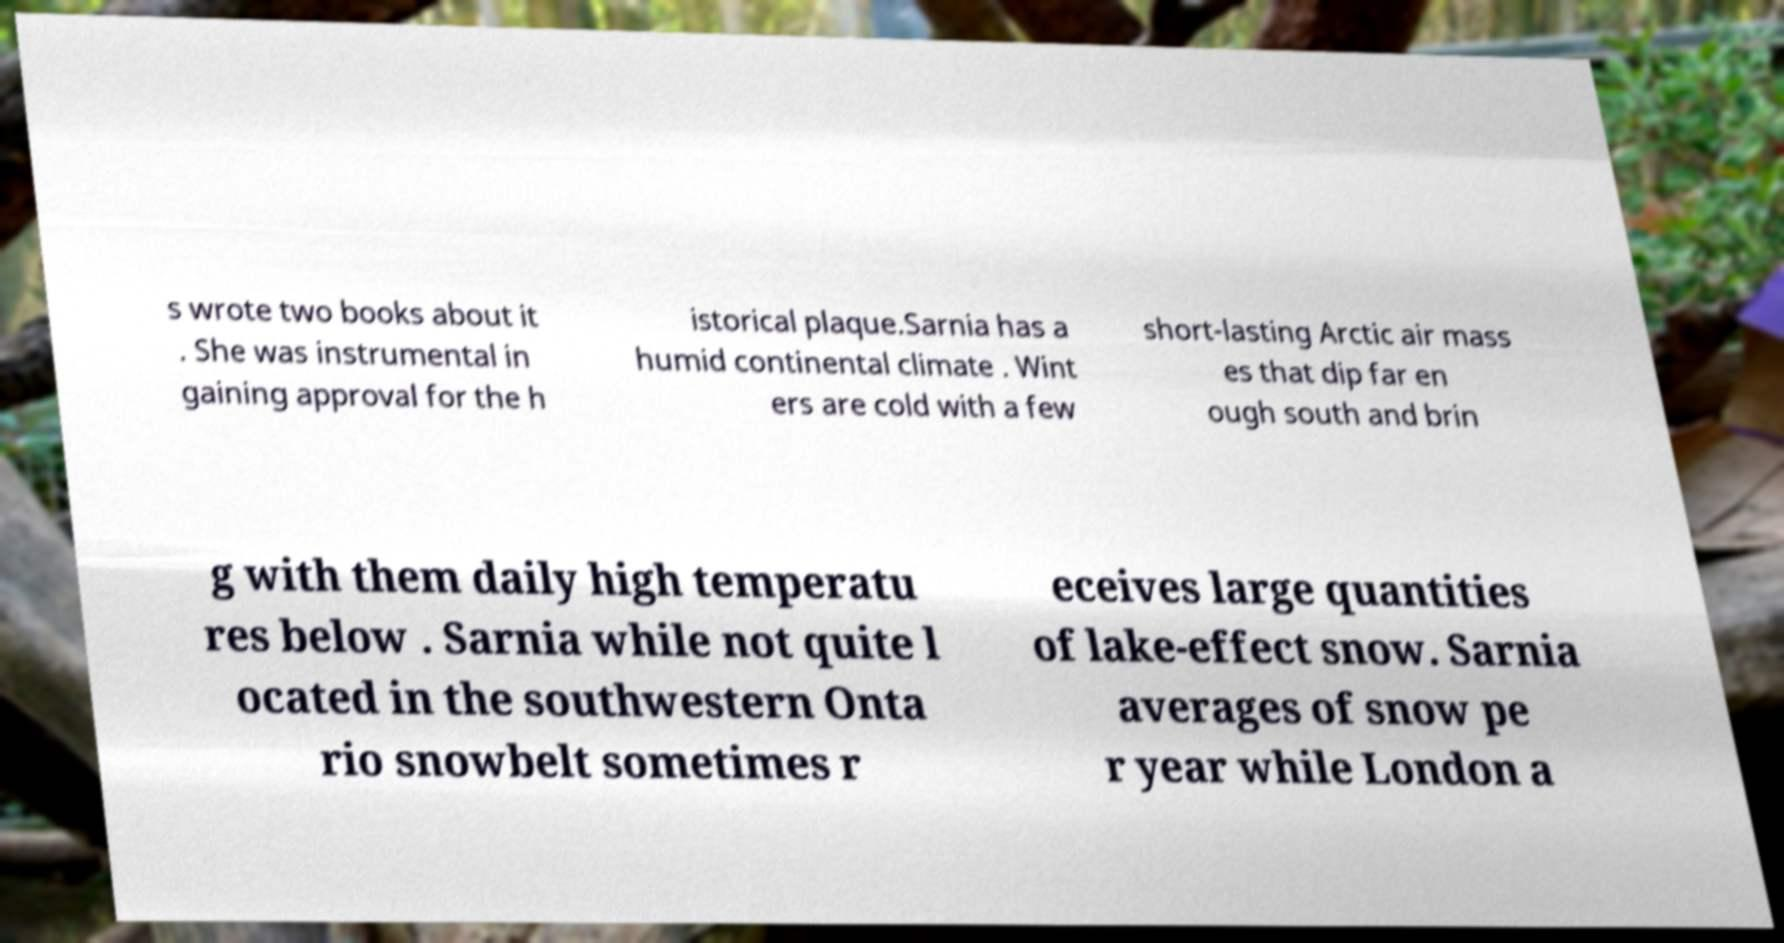What messages or text are displayed in this image? I need them in a readable, typed format. s wrote two books about it . She was instrumental in gaining approval for the h istorical plaque.Sarnia has a humid continental climate . Wint ers are cold with a few short-lasting Arctic air mass es that dip far en ough south and brin g with them daily high temperatu res below . Sarnia while not quite l ocated in the southwestern Onta rio snowbelt sometimes r eceives large quantities of lake-effect snow. Sarnia averages of snow pe r year while London a 